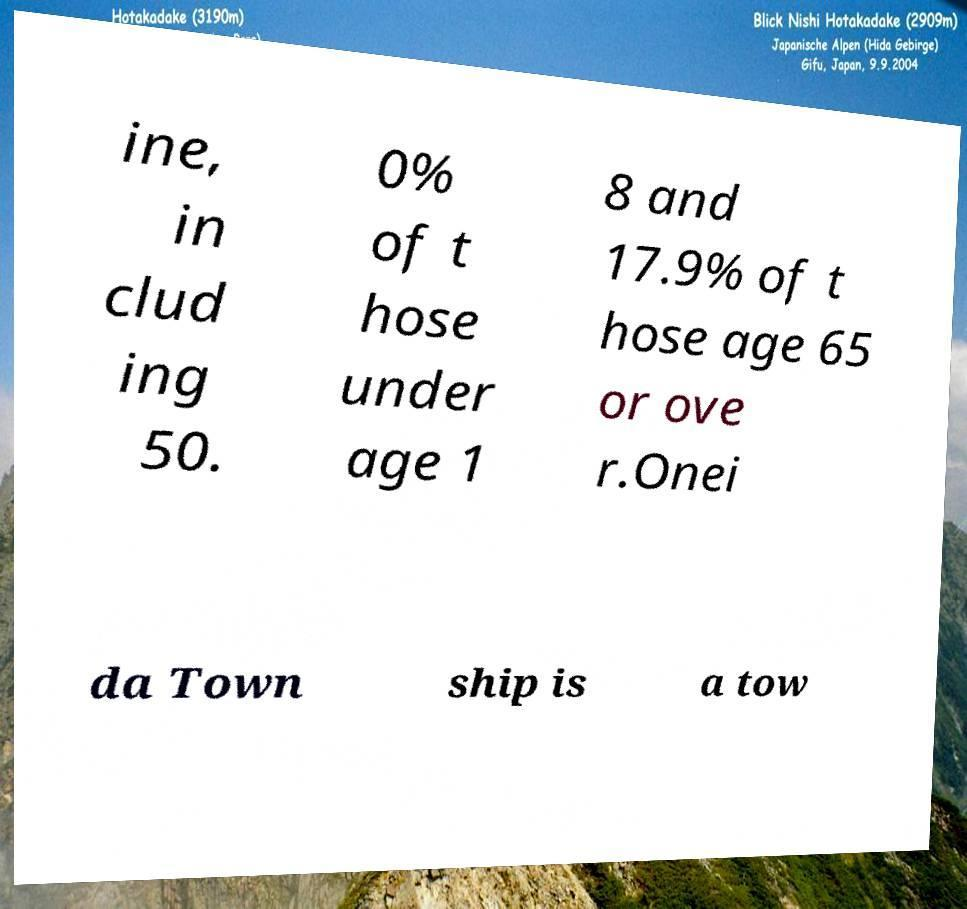Can you read and provide the text displayed in the image?This photo seems to have some interesting text. Can you extract and type it out for me? ine, in clud ing 50. 0% of t hose under age 1 8 and 17.9% of t hose age 65 or ove r.Onei da Town ship is a tow 